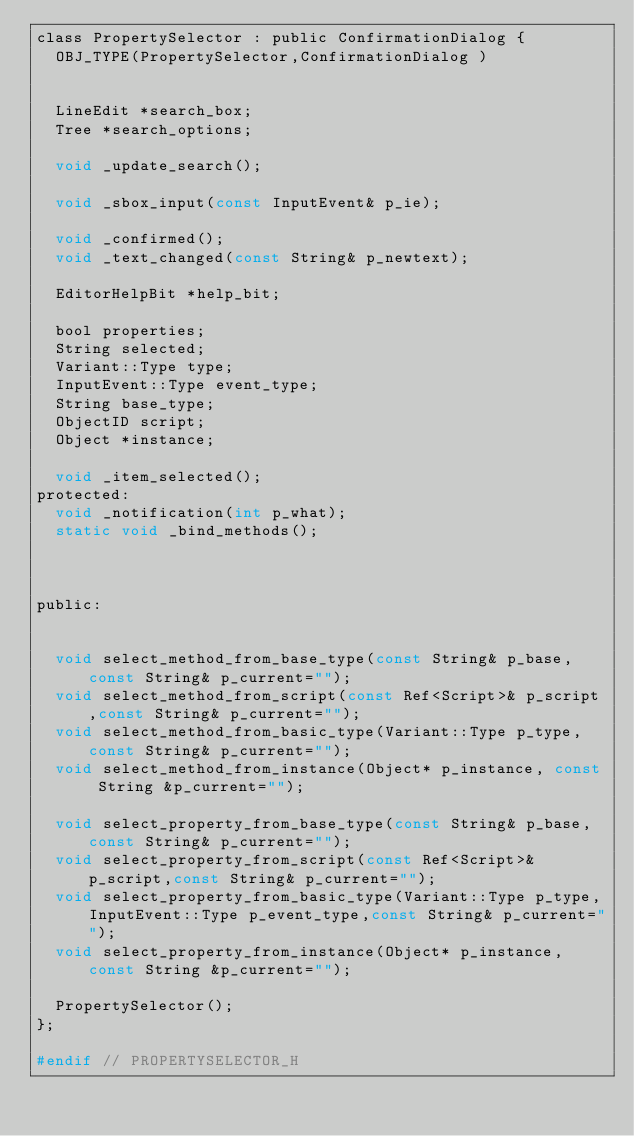Convert code to text. <code><loc_0><loc_0><loc_500><loc_500><_C_>class PropertySelector : public ConfirmationDialog {
	OBJ_TYPE(PropertySelector,ConfirmationDialog )


	LineEdit *search_box;
	Tree *search_options;

	void _update_search();

	void _sbox_input(const InputEvent& p_ie);

	void _confirmed();
	void _text_changed(const String& p_newtext);

	EditorHelpBit *help_bit;

	bool properties;
	String selected;
	Variant::Type type;
	InputEvent::Type event_type;
	String base_type;
	ObjectID script;
	Object *instance;

	void _item_selected();
protected:
	void _notification(int p_what);
	static void _bind_methods();



public:


	void select_method_from_base_type(const String& p_base,const String& p_current="");
	void select_method_from_script(const Ref<Script>& p_script,const String& p_current="");
	void select_method_from_basic_type(Variant::Type p_type,const String& p_current="");
	void select_method_from_instance(Object* p_instance, const String &p_current="");

	void select_property_from_base_type(const String& p_base,const String& p_current="");
	void select_property_from_script(const Ref<Script>& p_script,const String& p_current="");
	void select_property_from_basic_type(Variant::Type p_type,InputEvent::Type p_event_type,const String& p_current="");
	void select_property_from_instance(Object* p_instance, const String &p_current="");

	PropertySelector();
};

#endif // PROPERTYSELECTOR_H
</code> 